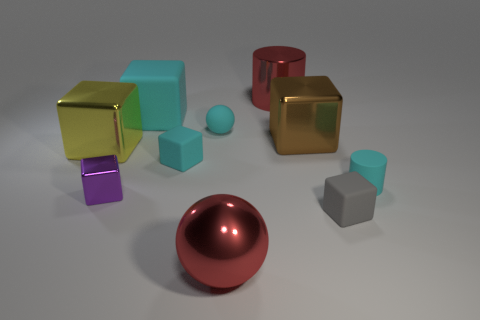Do the red shiny cylinder and the brown block have the same size?
Your answer should be compact. Yes. What is the material of the large brown thing?
Provide a short and direct response. Metal. There is a gray block that is the same size as the purple block; what is its material?
Provide a succinct answer. Rubber. Is there a matte block that has the same size as the red sphere?
Provide a short and direct response. Yes. Are there the same number of big yellow blocks that are behind the yellow metal thing and red metallic cylinders in front of the small gray cube?
Offer a very short reply. Yes. Are there more big cyan matte things than cyan things?
Make the answer very short. No. How many matte things are big red cylinders or small things?
Offer a very short reply. 4. How many balls have the same color as the metallic cylinder?
Ensure brevity in your answer.  1. There is a small cyan object on the right side of the ball that is behind the matte thing in front of the tiny purple cube; what is it made of?
Provide a short and direct response. Rubber. What is the color of the large metallic cylinder right of the big object that is in front of the purple shiny block?
Ensure brevity in your answer.  Red. 